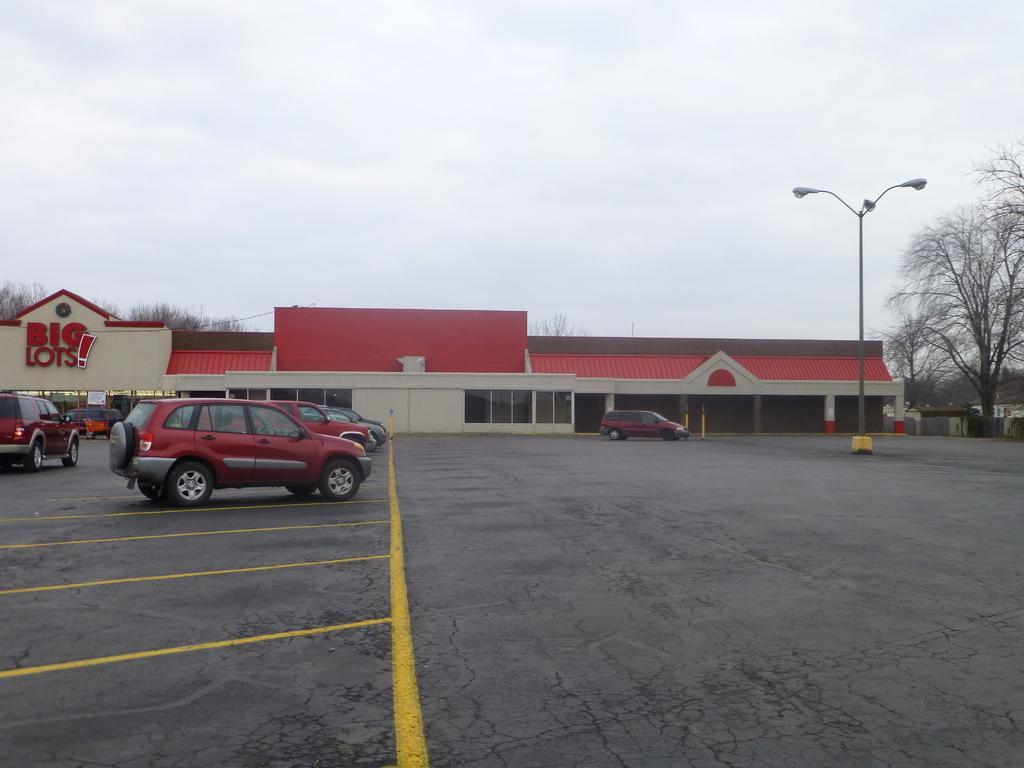Please provide a concise description of this image. At the bottom of the image there are few cars parked in a parking area. In the background there is a store with red roof, walls, pillars and glass windows. At the right side of the image there is a tree. At the top of the image there is a sky with clouds. 